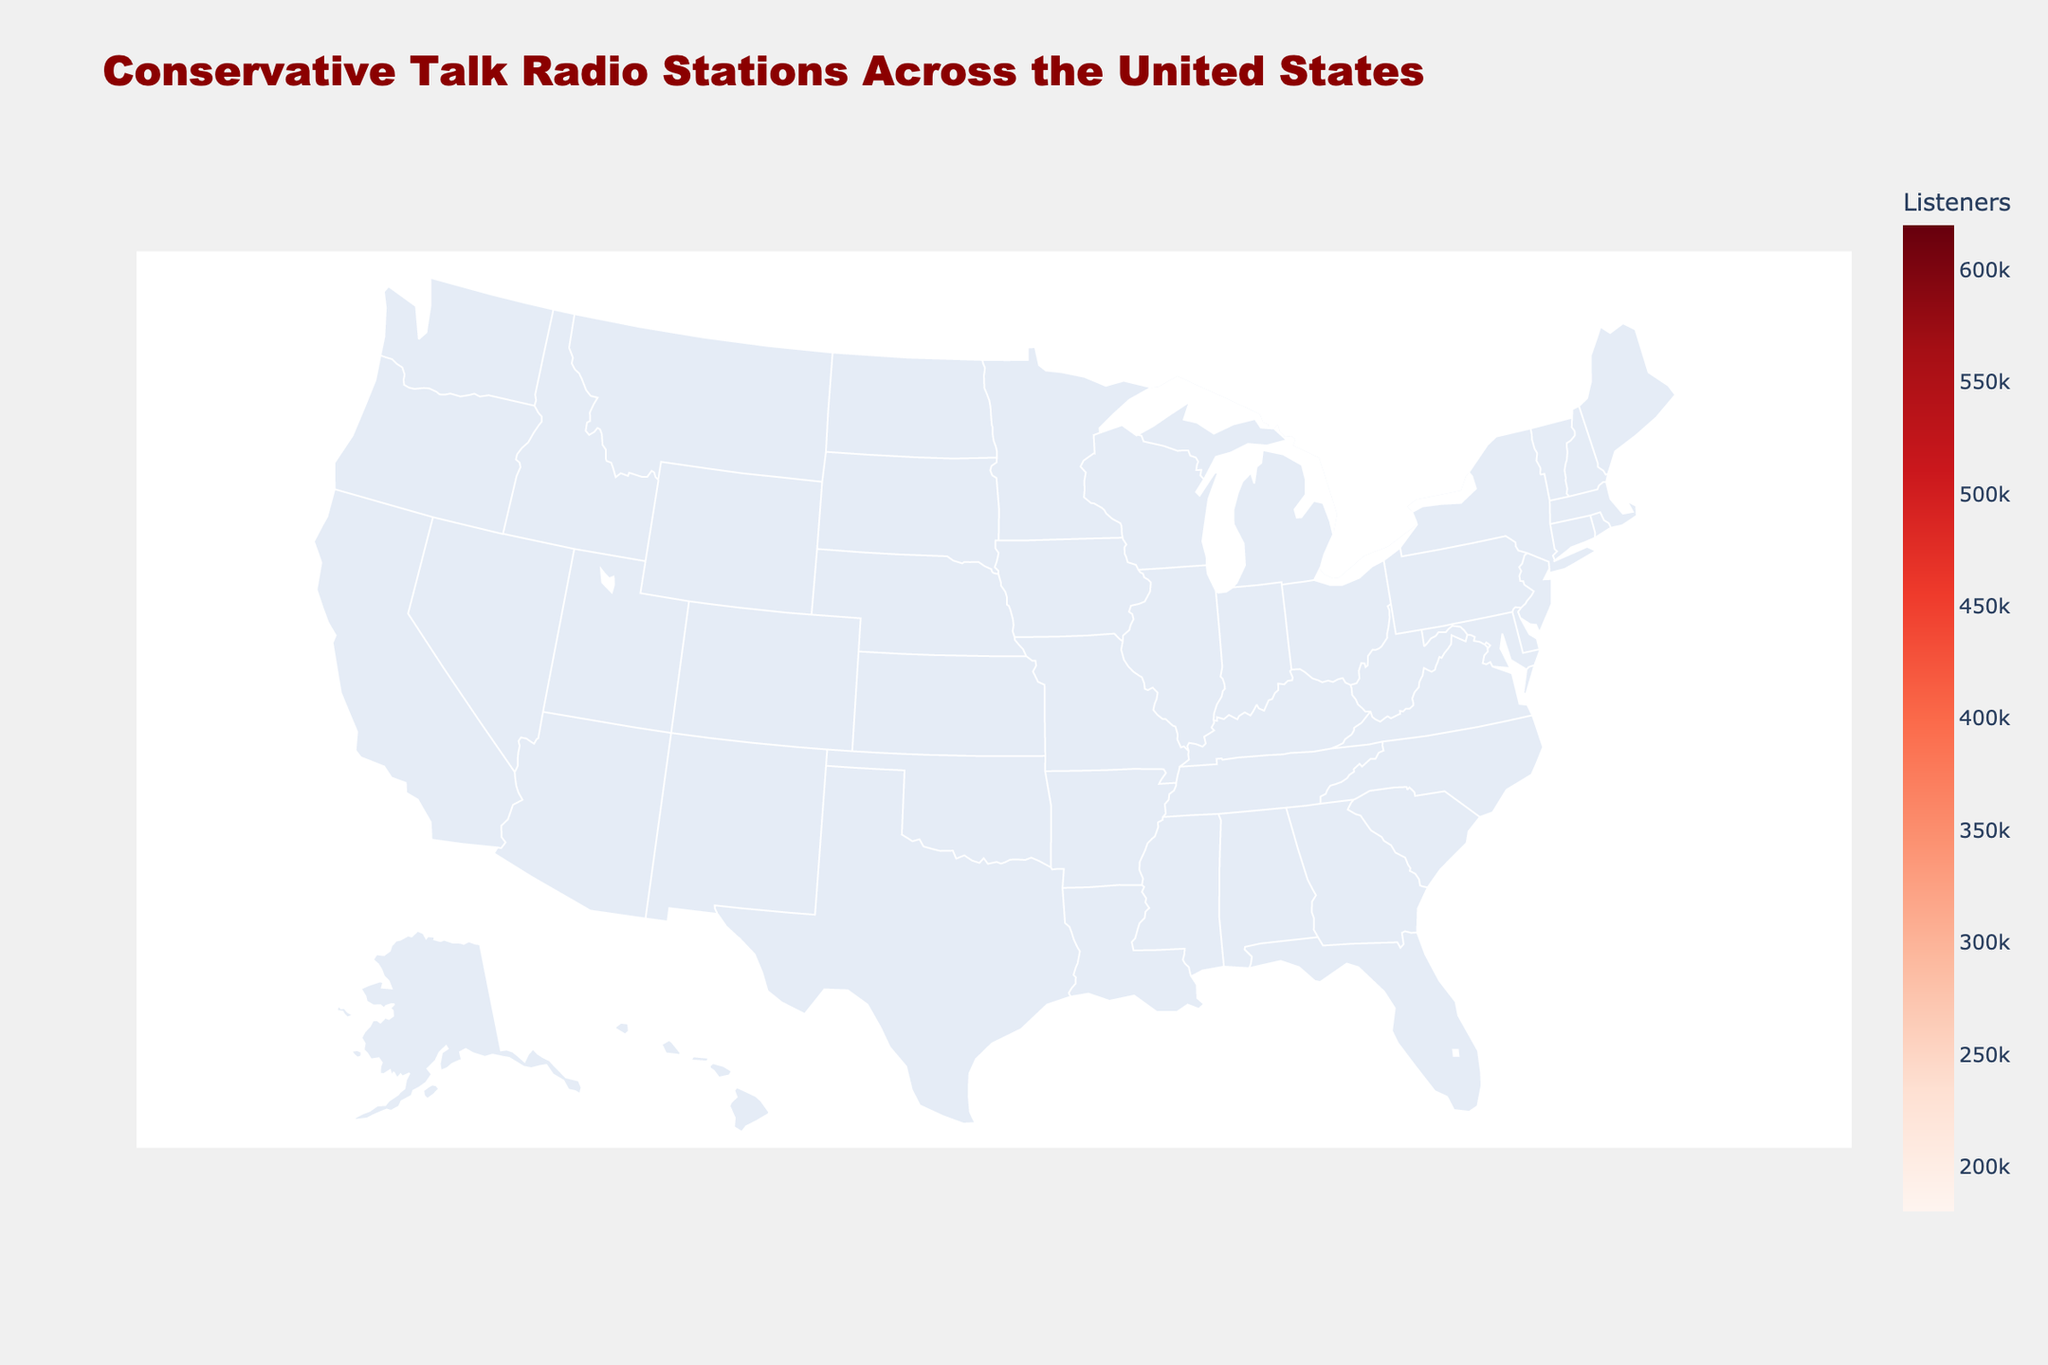How many states have conservative talk radio stations mentioned on the map? To determine the number of states with conservative talk radio stations, count the unique state names listed in the visual information provided in the legend or directly on the map.
Answer: 15 Which state has the highest number of listeners and what is the number? Identify the state that displays the highest value in the color scale or hover text for the number of listeners.
Answer: Texas, 620,000 Compare the Tea Party Affiliation levels: How many states fall into each category (Low, Medium, High)? Count how many states are represented in each Tea Party Affiliation category by examining the hover text or color coding.
Answer: Low: 1, Medium: 7, High: 7 What is the average age of listeners for states with a high Tea Party Affiliation? Locate the states categorized under high Tea Party Affiliation, then calculate the average age of listeners for these states. The states are: Arizona, Texas, Georgia, Michigan, Tennessee, South Carolina, Alabama, Oklahoma. The corresponding ages are 58, 55, 57, 60, 56, 64, 59, 57. Summing these up gives 422, and dividing by 8 gives 52.75.
Answer: 58.625 Which station has the highest percentage of male listeners? Locate the station with the highest value for male listeners by referring to the hover text or data points displayed on the map.
Answer: WTMA in South Carolina, 72% Between KFI in California and KTOK in Oklahoma, which station has more listeners? Compare the number of listeners for these two specific stations highlighted on the map.
Answer: KFI in California What is the combined number of listeners for the states that have a medium Tea Party Affiliation? Sum the number of listeners for all states with a medium Tea Party Affiliation. The states are Florida, Ohio, Pennsylvania, Virginia, Missouri, Nebraska. The listeners are 380,000 + 290,000 + 350,000 + 280,000 + 340,000 + 190,000. Summing these up gives 1,830,000.
Answer: 1,830,000 Which state has the oldest average listener age and what is the age? Identify the state with the highest average age value displayed on the map or in the hover text.
Answer: South Carolina, 64 